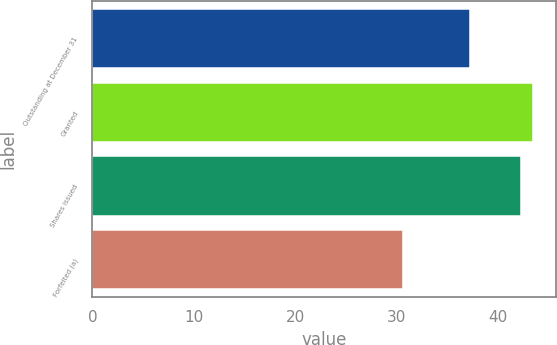Convert chart to OTSL. <chart><loc_0><loc_0><loc_500><loc_500><bar_chart><fcel>Outstanding at December 31<fcel>Granted<fcel>Shares issued<fcel>Forfeited (a)<nl><fcel>37.21<fcel>43.51<fcel>42.25<fcel>30.6<nl></chart> 